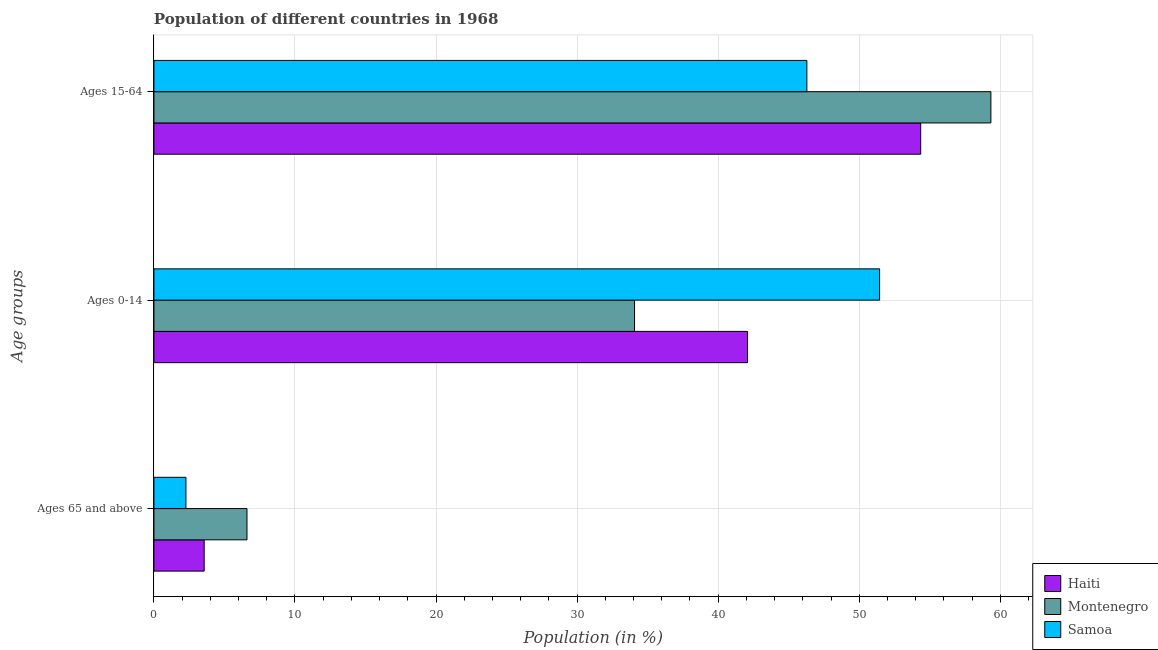How many different coloured bars are there?
Make the answer very short. 3. Are the number of bars on each tick of the Y-axis equal?
Your answer should be compact. Yes. How many bars are there on the 1st tick from the top?
Provide a succinct answer. 3. What is the label of the 1st group of bars from the top?
Provide a succinct answer. Ages 15-64. What is the percentage of population within the age-group of 65 and above in Samoa?
Ensure brevity in your answer.  2.27. Across all countries, what is the maximum percentage of population within the age-group of 65 and above?
Your answer should be very brief. 6.6. Across all countries, what is the minimum percentage of population within the age-group of 65 and above?
Offer a very short reply. 2.27. In which country was the percentage of population within the age-group of 65 and above maximum?
Provide a succinct answer. Montenegro. In which country was the percentage of population within the age-group 0-14 minimum?
Your answer should be very brief. Montenegro. What is the total percentage of population within the age-group 15-64 in the graph?
Provide a short and direct response. 159.98. What is the difference between the percentage of population within the age-group 0-14 in Samoa and that in Haiti?
Provide a short and direct response. 9.36. What is the difference between the percentage of population within the age-group 15-64 in Montenegro and the percentage of population within the age-group of 65 and above in Samoa?
Give a very brief answer. 57.06. What is the average percentage of population within the age-group 15-64 per country?
Provide a short and direct response. 53.33. What is the difference between the percentage of population within the age-group of 65 and above and percentage of population within the age-group 0-14 in Samoa?
Provide a succinct answer. -49.17. What is the ratio of the percentage of population within the age-group of 65 and above in Samoa to that in Haiti?
Provide a succinct answer. 0.64. What is the difference between the highest and the second highest percentage of population within the age-group 15-64?
Your response must be concise. 4.98. What is the difference between the highest and the lowest percentage of population within the age-group 0-14?
Offer a terse response. 17.37. In how many countries, is the percentage of population within the age-group of 65 and above greater than the average percentage of population within the age-group of 65 and above taken over all countries?
Your answer should be compact. 1. Is the sum of the percentage of population within the age-group 15-64 in Montenegro and Samoa greater than the maximum percentage of population within the age-group of 65 and above across all countries?
Provide a short and direct response. Yes. What does the 3rd bar from the top in Ages 0-14 represents?
Keep it short and to the point. Haiti. What does the 1st bar from the bottom in Ages 15-64 represents?
Offer a terse response. Haiti. Is it the case that in every country, the sum of the percentage of population within the age-group of 65 and above and percentage of population within the age-group 0-14 is greater than the percentage of population within the age-group 15-64?
Your answer should be very brief. No. How many bars are there?
Keep it short and to the point. 9. How many countries are there in the graph?
Keep it short and to the point. 3. What is the difference between two consecutive major ticks on the X-axis?
Your answer should be compact. 10. Are the values on the major ticks of X-axis written in scientific E-notation?
Offer a very short reply. No. Where does the legend appear in the graph?
Your response must be concise. Bottom right. What is the title of the graph?
Provide a succinct answer. Population of different countries in 1968. Does "Senegal" appear as one of the legend labels in the graph?
Ensure brevity in your answer.  No. What is the label or title of the Y-axis?
Provide a short and direct response. Age groups. What is the Population (in %) of Haiti in Ages 65 and above?
Give a very brief answer. 3.56. What is the Population (in %) of Montenegro in Ages 65 and above?
Give a very brief answer. 6.6. What is the Population (in %) in Samoa in Ages 65 and above?
Provide a short and direct response. 2.27. What is the Population (in %) of Haiti in Ages 0-14?
Provide a succinct answer. 42.08. What is the Population (in %) in Montenegro in Ages 0-14?
Your answer should be compact. 34.07. What is the Population (in %) in Samoa in Ages 0-14?
Give a very brief answer. 51.44. What is the Population (in %) in Haiti in Ages 15-64?
Provide a short and direct response. 54.36. What is the Population (in %) in Montenegro in Ages 15-64?
Provide a short and direct response. 59.33. What is the Population (in %) of Samoa in Ages 15-64?
Your answer should be very brief. 46.29. Across all Age groups, what is the maximum Population (in %) in Haiti?
Give a very brief answer. 54.36. Across all Age groups, what is the maximum Population (in %) in Montenegro?
Give a very brief answer. 59.33. Across all Age groups, what is the maximum Population (in %) in Samoa?
Provide a succinct answer. 51.44. Across all Age groups, what is the minimum Population (in %) of Haiti?
Keep it short and to the point. 3.56. Across all Age groups, what is the minimum Population (in %) of Montenegro?
Offer a terse response. 6.6. Across all Age groups, what is the minimum Population (in %) of Samoa?
Ensure brevity in your answer.  2.27. What is the total Population (in %) of Haiti in the graph?
Offer a very short reply. 100. What is the total Population (in %) in Montenegro in the graph?
Offer a very short reply. 100. What is the difference between the Population (in %) in Haiti in Ages 65 and above and that in Ages 0-14?
Provide a succinct answer. -38.52. What is the difference between the Population (in %) of Montenegro in Ages 65 and above and that in Ages 0-14?
Ensure brevity in your answer.  -27.47. What is the difference between the Population (in %) in Samoa in Ages 65 and above and that in Ages 0-14?
Your response must be concise. -49.17. What is the difference between the Population (in %) in Haiti in Ages 65 and above and that in Ages 15-64?
Your answer should be very brief. -50.79. What is the difference between the Population (in %) in Montenegro in Ages 65 and above and that in Ages 15-64?
Provide a succinct answer. -52.74. What is the difference between the Population (in %) in Samoa in Ages 65 and above and that in Ages 15-64?
Your answer should be compact. -44.02. What is the difference between the Population (in %) of Haiti in Ages 0-14 and that in Ages 15-64?
Keep it short and to the point. -12.28. What is the difference between the Population (in %) in Montenegro in Ages 0-14 and that in Ages 15-64?
Ensure brevity in your answer.  -25.26. What is the difference between the Population (in %) of Samoa in Ages 0-14 and that in Ages 15-64?
Ensure brevity in your answer.  5.16. What is the difference between the Population (in %) in Haiti in Ages 65 and above and the Population (in %) in Montenegro in Ages 0-14?
Make the answer very short. -30.51. What is the difference between the Population (in %) in Haiti in Ages 65 and above and the Population (in %) in Samoa in Ages 0-14?
Provide a short and direct response. -47.88. What is the difference between the Population (in %) of Montenegro in Ages 65 and above and the Population (in %) of Samoa in Ages 0-14?
Make the answer very short. -44.85. What is the difference between the Population (in %) in Haiti in Ages 65 and above and the Population (in %) in Montenegro in Ages 15-64?
Make the answer very short. -55.77. What is the difference between the Population (in %) in Haiti in Ages 65 and above and the Population (in %) in Samoa in Ages 15-64?
Offer a terse response. -42.72. What is the difference between the Population (in %) in Montenegro in Ages 65 and above and the Population (in %) in Samoa in Ages 15-64?
Make the answer very short. -39.69. What is the difference between the Population (in %) in Haiti in Ages 0-14 and the Population (in %) in Montenegro in Ages 15-64?
Ensure brevity in your answer.  -17.25. What is the difference between the Population (in %) of Haiti in Ages 0-14 and the Population (in %) of Samoa in Ages 15-64?
Provide a short and direct response. -4.21. What is the difference between the Population (in %) in Montenegro in Ages 0-14 and the Population (in %) in Samoa in Ages 15-64?
Offer a terse response. -12.22. What is the average Population (in %) in Haiti per Age groups?
Offer a very short reply. 33.33. What is the average Population (in %) in Montenegro per Age groups?
Provide a succinct answer. 33.33. What is the average Population (in %) in Samoa per Age groups?
Offer a very short reply. 33.33. What is the difference between the Population (in %) of Haiti and Population (in %) of Montenegro in Ages 65 and above?
Provide a short and direct response. -3.03. What is the difference between the Population (in %) in Haiti and Population (in %) in Samoa in Ages 65 and above?
Give a very brief answer. 1.29. What is the difference between the Population (in %) in Montenegro and Population (in %) in Samoa in Ages 65 and above?
Provide a short and direct response. 4.33. What is the difference between the Population (in %) in Haiti and Population (in %) in Montenegro in Ages 0-14?
Your response must be concise. 8.01. What is the difference between the Population (in %) of Haiti and Population (in %) of Samoa in Ages 0-14?
Your answer should be very brief. -9.36. What is the difference between the Population (in %) in Montenegro and Population (in %) in Samoa in Ages 0-14?
Ensure brevity in your answer.  -17.37. What is the difference between the Population (in %) of Haiti and Population (in %) of Montenegro in Ages 15-64?
Your answer should be compact. -4.98. What is the difference between the Population (in %) of Haiti and Population (in %) of Samoa in Ages 15-64?
Give a very brief answer. 8.07. What is the difference between the Population (in %) of Montenegro and Population (in %) of Samoa in Ages 15-64?
Ensure brevity in your answer.  13.05. What is the ratio of the Population (in %) of Haiti in Ages 65 and above to that in Ages 0-14?
Your answer should be very brief. 0.08. What is the ratio of the Population (in %) in Montenegro in Ages 65 and above to that in Ages 0-14?
Make the answer very short. 0.19. What is the ratio of the Population (in %) of Samoa in Ages 65 and above to that in Ages 0-14?
Offer a terse response. 0.04. What is the ratio of the Population (in %) in Haiti in Ages 65 and above to that in Ages 15-64?
Your response must be concise. 0.07. What is the ratio of the Population (in %) of Montenegro in Ages 65 and above to that in Ages 15-64?
Your response must be concise. 0.11. What is the ratio of the Population (in %) in Samoa in Ages 65 and above to that in Ages 15-64?
Provide a short and direct response. 0.05. What is the ratio of the Population (in %) of Haiti in Ages 0-14 to that in Ages 15-64?
Make the answer very short. 0.77. What is the ratio of the Population (in %) of Montenegro in Ages 0-14 to that in Ages 15-64?
Give a very brief answer. 0.57. What is the ratio of the Population (in %) in Samoa in Ages 0-14 to that in Ages 15-64?
Your answer should be very brief. 1.11. What is the difference between the highest and the second highest Population (in %) in Haiti?
Offer a terse response. 12.28. What is the difference between the highest and the second highest Population (in %) in Montenegro?
Your answer should be very brief. 25.26. What is the difference between the highest and the second highest Population (in %) in Samoa?
Your answer should be compact. 5.16. What is the difference between the highest and the lowest Population (in %) of Haiti?
Your answer should be compact. 50.79. What is the difference between the highest and the lowest Population (in %) in Montenegro?
Provide a short and direct response. 52.74. What is the difference between the highest and the lowest Population (in %) of Samoa?
Offer a very short reply. 49.17. 